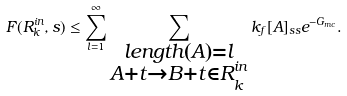<formula> <loc_0><loc_0><loc_500><loc_500>F ( R ^ { i n } _ { k } , s ) \leq \sum _ { l = 1 } ^ { \infty } \sum _ { \substack { l e n g t h ( A ) = l \\ A + t \rightarrow B + t \in R ^ { i n } _ { k } } } k _ { f } [ A ] _ { s s } e ^ { - G _ { m c } } .</formula> 